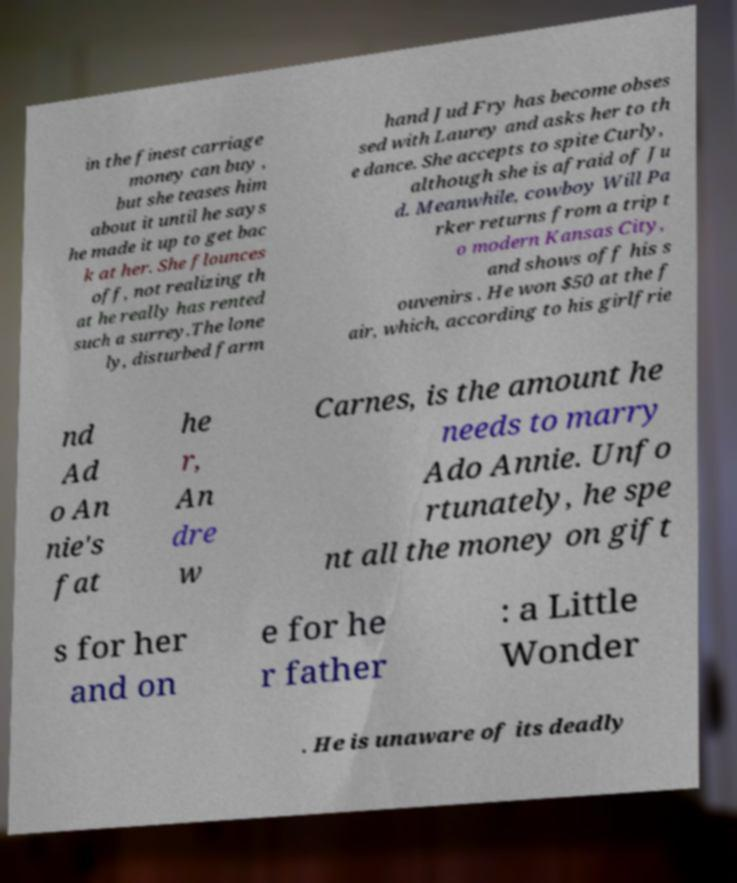What messages or text are displayed in this image? I need them in a readable, typed format. in the finest carriage money can buy , but she teases him about it until he says he made it up to get bac k at her. She flounces off, not realizing th at he really has rented such a surrey.The lone ly, disturbed farm hand Jud Fry has become obses sed with Laurey and asks her to th e dance. She accepts to spite Curly, although she is afraid of Ju d. Meanwhile, cowboy Will Pa rker returns from a trip t o modern Kansas City, and shows off his s ouvenirs . He won $50 at the f air, which, according to his girlfrie nd Ad o An nie's fat he r, An dre w Carnes, is the amount he needs to marry Ado Annie. Unfo rtunately, he spe nt all the money on gift s for her and on e for he r father : a Little Wonder . He is unaware of its deadly 